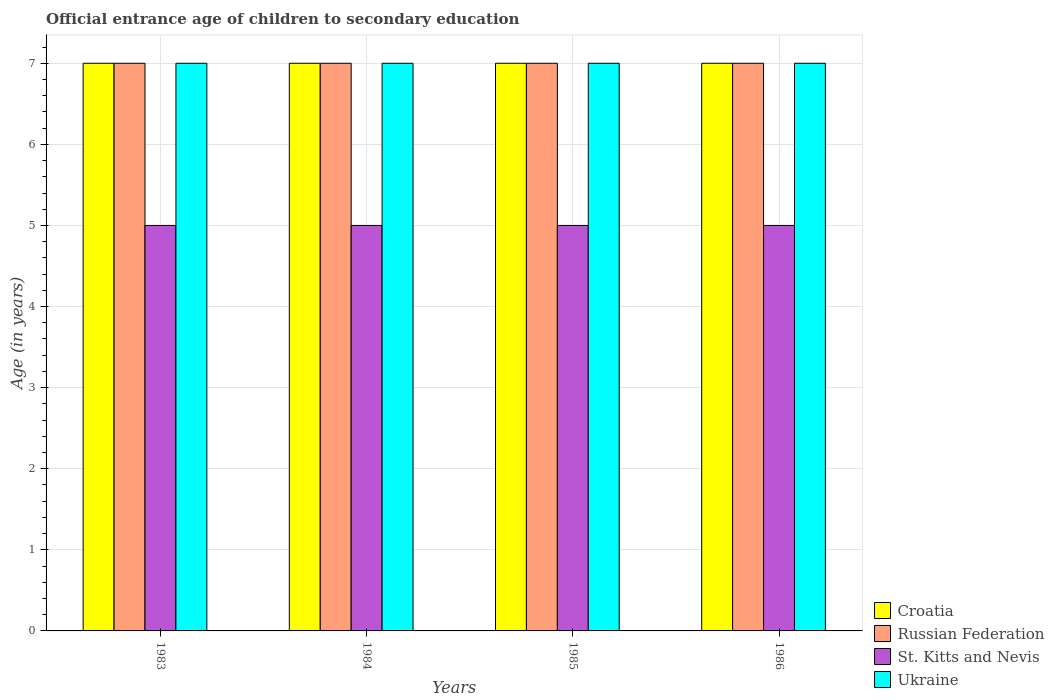How many different coloured bars are there?
Provide a short and direct response. 4. How many groups of bars are there?
Your answer should be compact. 4. Are the number of bars per tick equal to the number of legend labels?
Your answer should be very brief. Yes. Are the number of bars on each tick of the X-axis equal?
Offer a very short reply. Yes. How many bars are there on the 1st tick from the right?
Your answer should be very brief. 4. In how many cases, is the number of bars for a given year not equal to the number of legend labels?
Keep it short and to the point. 0. What is the secondary school starting age of children in Ukraine in 1985?
Your answer should be compact. 7. Across all years, what is the maximum secondary school starting age of children in Ukraine?
Provide a succinct answer. 7. Across all years, what is the minimum secondary school starting age of children in Ukraine?
Ensure brevity in your answer.  7. In which year was the secondary school starting age of children in St. Kitts and Nevis maximum?
Keep it short and to the point. 1983. What is the total secondary school starting age of children in St. Kitts and Nevis in the graph?
Offer a very short reply. 20. What is the difference between the secondary school starting age of children in Croatia in 1986 and the secondary school starting age of children in St. Kitts and Nevis in 1984?
Ensure brevity in your answer.  2. In the year 1986, what is the difference between the secondary school starting age of children in Ukraine and secondary school starting age of children in Croatia?
Your response must be concise. 0. What is the ratio of the secondary school starting age of children in Croatia in 1983 to that in 1986?
Your answer should be very brief. 1. Is the secondary school starting age of children in Croatia in 1984 less than that in 1986?
Offer a very short reply. No. Is the difference between the secondary school starting age of children in Ukraine in 1985 and 1986 greater than the difference between the secondary school starting age of children in Croatia in 1985 and 1986?
Your response must be concise. No. What is the difference between the highest and the second highest secondary school starting age of children in Croatia?
Give a very brief answer. 0. In how many years, is the secondary school starting age of children in St. Kitts and Nevis greater than the average secondary school starting age of children in St. Kitts and Nevis taken over all years?
Provide a succinct answer. 0. Is it the case that in every year, the sum of the secondary school starting age of children in Ukraine and secondary school starting age of children in St. Kitts and Nevis is greater than the sum of secondary school starting age of children in Russian Federation and secondary school starting age of children in Croatia?
Your response must be concise. No. What does the 4th bar from the left in 1985 represents?
Provide a short and direct response. Ukraine. What does the 3rd bar from the right in 1986 represents?
Your answer should be compact. Russian Federation. How many bars are there?
Ensure brevity in your answer.  16. How many years are there in the graph?
Your response must be concise. 4. Does the graph contain any zero values?
Offer a very short reply. No. Does the graph contain grids?
Keep it short and to the point. Yes. Where does the legend appear in the graph?
Keep it short and to the point. Bottom right. How are the legend labels stacked?
Offer a very short reply. Vertical. What is the title of the graph?
Keep it short and to the point. Official entrance age of children to secondary education. Does "Greenland" appear as one of the legend labels in the graph?
Provide a short and direct response. No. What is the label or title of the X-axis?
Offer a terse response. Years. What is the label or title of the Y-axis?
Keep it short and to the point. Age (in years). What is the Age (in years) of Croatia in 1983?
Give a very brief answer. 7. What is the Age (in years) in Russian Federation in 1983?
Keep it short and to the point. 7. What is the Age (in years) of St. Kitts and Nevis in 1983?
Keep it short and to the point. 5. What is the Age (in years) of Ukraine in 1983?
Provide a succinct answer. 7. What is the Age (in years) of Croatia in 1984?
Your answer should be very brief. 7. What is the Age (in years) in Russian Federation in 1984?
Give a very brief answer. 7. What is the Age (in years) in St. Kitts and Nevis in 1985?
Your response must be concise. 5. What is the Age (in years) in Ukraine in 1985?
Ensure brevity in your answer.  7. Across all years, what is the maximum Age (in years) of Russian Federation?
Offer a terse response. 7. Across all years, what is the maximum Age (in years) of St. Kitts and Nevis?
Keep it short and to the point. 5. Across all years, what is the minimum Age (in years) in Croatia?
Provide a succinct answer. 7. Across all years, what is the minimum Age (in years) of St. Kitts and Nevis?
Make the answer very short. 5. What is the total Age (in years) of Croatia in the graph?
Give a very brief answer. 28. What is the total Age (in years) of St. Kitts and Nevis in the graph?
Provide a succinct answer. 20. What is the difference between the Age (in years) in Croatia in 1983 and that in 1984?
Provide a short and direct response. 0. What is the difference between the Age (in years) in St. Kitts and Nevis in 1983 and that in 1984?
Offer a terse response. 0. What is the difference between the Age (in years) in Ukraine in 1983 and that in 1984?
Provide a short and direct response. 0. What is the difference between the Age (in years) in Croatia in 1983 and that in 1985?
Your answer should be compact. 0. What is the difference between the Age (in years) of Croatia in 1983 and that in 1986?
Ensure brevity in your answer.  0. What is the difference between the Age (in years) in Russian Federation in 1983 and that in 1986?
Offer a very short reply. 0. What is the difference between the Age (in years) in St. Kitts and Nevis in 1983 and that in 1986?
Provide a succinct answer. 0. What is the difference between the Age (in years) of Croatia in 1984 and that in 1985?
Offer a terse response. 0. What is the difference between the Age (in years) in Russian Federation in 1984 and that in 1985?
Keep it short and to the point. 0. What is the difference between the Age (in years) in Croatia in 1984 and that in 1986?
Ensure brevity in your answer.  0. What is the difference between the Age (in years) of Russian Federation in 1984 and that in 1986?
Ensure brevity in your answer.  0. What is the difference between the Age (in years) in Croatia in 1985 and that in 1986?
Offer a very short reply. 0. What is the difference between the Age (in years) in Russian Federation in 1985 and that in 1986?
Make the answer very short. 0. What is the difference between the Age (in years) in Croatia in 1983 and the Age (in years) in St. Kitts and Nevis in 1984?
Your answer should be compact. 2. What is the difference between the Age (in years) of Russian Federation in 1983 and the Age (in years) of St. Kitts and Nevis in 1984?
Keep it short and to the point. 2. What is the difference between the Age (in years) of Russian Federation in 1983 and the Age (in years) of Ukraine in 1984?
Your answer should be very brief. 0. What is the difference between the Age (in years) of St. Kitts and Nevis in 1983 and the Age (in years) of Ukraine in 1984?
Ensure brevity in your answer.  -2. What is the difference between the Age (in years) of Croatia in 1983 and the Age (in years) of Russian Federation in 1985?
Offer a terse response. 0. What is the difference between the Age (in years) of Russian Federation in 1983 and the Age (in years) of St. Kitts and Nevis in 1985?
Your answer should be compact. 2. What is the difference between the Age (in years) of St. Kitts and Nevis in 1983 and the Age (in years) of Ukraine in 1985?
Offer a terse response. -2. What is the difference between the Age (in years) in Croatia in 1983 and the Age (in years) in Russian Federation in 1986?
Offer a very short reply. 0. What is the difference between the Age (in years) of Croatia in 1983 and the Age (in years) of St. Kitts and Nevis in 1986?
Your answer should be compact. 2. What is the difference between the Age (in years) of Croatia in 1983 and the Age (in years) of Ukraine in 1986?
Offer a terse response. 0. What is the difference between the Age (in years) in Russian Federation in 1983 and the Age (in years) in St. Kitts and Nevis in 1986?
Provide a succinct answer. 2. What is the difference between the Age (in years) of St. Kitts and Nevis in 1983 and the Age (in years) of Ukraine in 1986?
Ensure brevity in your answer.  -2. What is the difference between the Age (in years) of Croatia in 1984 and the Age (in years) of Russian Federation in 1985?
Provide a short and direct response. 0. What is the difference between the Age (in years) in Russian Federation in 1984 and the Age (in years) in St. Kitts and Nevis in 1985?
Give a very brief answer. 2. What is the difference between the Age (in years) of Russian Federation in 1984 and the Age (in years) of Ukraine in 1985?
Your answer should be compact. 0. What is the difference between the Age (in years) of Croatia in 1984 and the Age (in years) of Russian Federation in 1986?
Provide a short and direct response. 0. What is the difference between the Age (in years) in Russian Federation in 1984 and the Age (in years) in Ukraine in 1986?
Make the answer very short. 0. What is the difference between the Age (in years) in Croatia in 1985 and the Age (in years) in St. Kitts and Nevis in 1986?
Your answer should be compact. 2. What is the average Age (in years) of St. Kitts and Nevis per year?
Offer a very short reply. 5. What is the average Age (in years) in Ukraine per year?
Provide a succinct answer. 7. In the year 1983, what is the difference between the Age (in years) of Croatia and Age (in years) of Russian Federation?
Ensure brevity in your answer.  0. In the year 1983, what is the difference between the Age (in years) in Croatia and Age (in years) in St. Kitts and Nevis?
Your answer should be very brief. 2. In the year 1983, what is the difference between the Age (in years) in Croatia and Age (in years) in Ukraine?
Your answer should be very brief. 0. In the year 1983, what is the difference between the Age (in years) in Russian Federation and Age (in years) in St. Kitts and Nevis?
Make the answer very short. 2. In the year 1984, what is the difference between the Age (in years) in Croatia and Age (in years) in Russian Federation?
Your answer should be compact. 0. In the year 1984, what is the difference between the Age (in years) of Croatia and Age (in years) of Ukraine?
Keep it short and to the point. 0. In the year 1984, what is the difference between the Age (in years) of Russian Federation and Age (in years) of St. Kitts and Nevis?
Provide a short and direct response. 2. In the year 1984, what is the difference between the Age (in years) in St. Kitts and Nevis and Age (in years) in Ukraine?
Provide a succinct answer. -2. In the year 1985, what is the difference between the Age (in years) in Croatia and Age (in years) in Russian Federation?
Provide a short and direct response. 0. In the year 1985, what is the difference between the Age (in years) in Croatia and Age (in years) in St. Kitts and Nevis?
Provide a short and direct response. 2. In the year 1985, what is the difference between the Age (in years) in Croatia and Age (in years) in Ukraine?
Your answer should be very brief. 0. In the year 1985, what is the difference between the Age (in years) in Russian Federation and Age (in years) in St. Kitts and Nevis?
Offer a very short reply. 2. In the year 1985, what is the difference between the Age (in years) in Russian Federation and Age (in years) in Ukraine?
Offer a very short reply. 0. In the year 1985, what is the difference between the Age (in years) in St. Kitts and Nevis and Age (in years) in Ukraine?
Offer a terse response. -2. In the year 1986, what is the difference between the Age (in years) of Croatia and Age (in years) of Russian Federation?
Provide a succinct answer. 0. In the year 1986, what is the difference between the Age (in years) of Croatia and Age (in years) of St. Kitts and Nevis?
Give a very brief answer. 2. In the year 1986, what is the difference between the Age (in years) of Croatia and Age (in years) of Ukraine?
Your answer should be compact. 0. In the year 1986, what is the difference between the Age (in years) of St. Kitts and Nevis and Age (in years) of Ukraine?
Your response must be concise. -2. What is the ratio of the Age (in years) of St. Kitts and Nevis in 1983 to that in 1984?
Provide a short and direct response. 1. What is the ratio of the Age (in years) of Ukraine in 1983 to that in 1984?
Your answer should be compact. 1. What is the ratio of the Age (in years) of Croatia in 1983 to that in 1985?
Offer a terse response. 1. What is the ratio of the Age (in years) of Russian Federation in 1983 to that in 1985?
Ensure brevity in your answer.  1. What is the ratio of the Age (in years) in St. Kitts and Nevis in 1983 to that in 1985?
Offer a terse response. 1. What is the ratio of the Age (in years) of Croatia in 1984 to that in 1985?
Give a very brief answer. 1. What is the ratio of the Age (in years) of Russian Federation in 1984 to that in 1985?
Your answer should be compact. 1. What is the ratio of the Age (in years) in St. Kitts and Nevis in 1984 to that in 1985?
Give a very brief answer. 1. What is the ratio of the Age (in years) in Croatia in 1984 to that in 1986?
Keep it short and to the point. 1. What is the ratio of the Age (in years) in St. Kitts and Nevis in 1984 to that in 1986?
Offer a terse response. 1. What is the ratio of the Age (in years) of Ukraine in 1985 to that in 1986?
Your answer should be compact. 1. What is the difference between the highest and the second highest Age (in years) in Ukraine?
Your answer should be compact. 0. What is the difference between the highest and the lowest Age (in years) in St. Kitts and Nevis?
Your answer should be very brief. 0. 